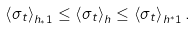Convert formula to latex. <formula><loc_0><loc_0><loc_500><loc_500>\left \langle \sigma _ { t } \right \rangle _ { h _ { * } \mathbf 1 } \leq \left \langle \sigma _ { t } \right \rangle _ { h } \leq \left \langle \sigma _ { t } \right \rangle _ { h ^ { * } \mathbf 1 } .</formula> 